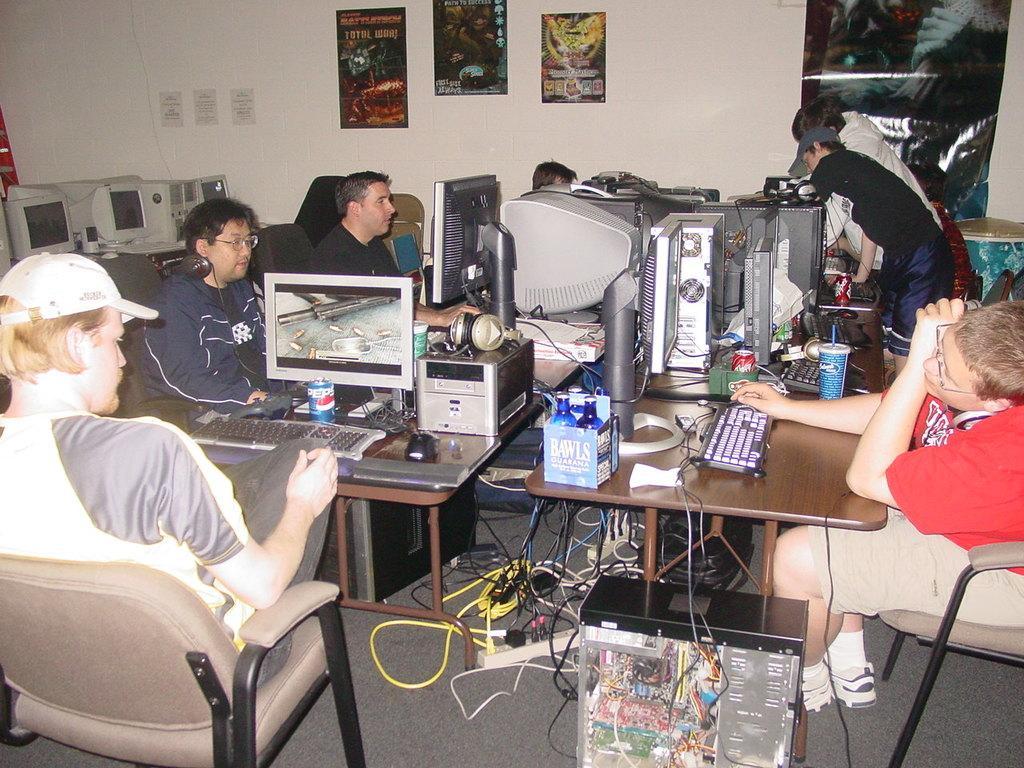Please provide a concise description of this image. Few persons are sitting on the chairs and few persons are standing. We can see monitors,keyboards,tin,bottles,box,headsets,mouse on the tables. We can see cables ,electrical device on the floor. On the background we can see wall,posters. 